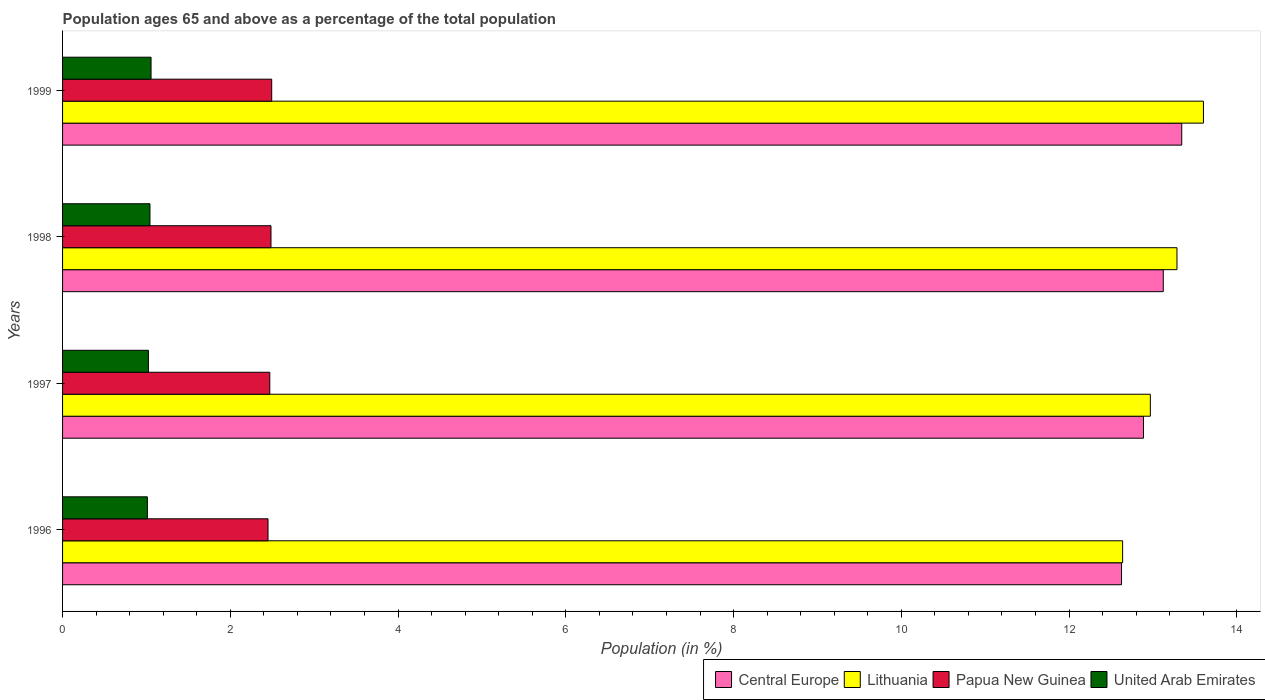How many different coloured bars are there?
Provide a succinct answer. 4. Are the number of bars on each tick of the Y-axis equal?
Ensure brevity in your answer.  Yes. How many bars are there on the 3rd tick from the top?
Provide a short and direct response. 4. How many bars are there on the 2nd tick from the bottom?
Make the answer very short. 4. In how many cases, is the number of bars for a given year not equal to the number of legend labels?
Your response must be concise. 0. What is the percentage of the population ages 65 and above in United Arab Emirates in 1999?
Your answer should be very brief. 1.05. Across all years, what is the maximum percentage of the population ages 65 and above in Papua New Guinea?
Provide a short and direct response. 2.49. Across all years, what is the minimum percentage of the population ages 65 and above in Papua New Guinea?
Keep it short and to the point. 2.45. In which year was the percentage of the population ages 65 and above in Central Europe minimum?
Offer a terse response. 1996. What is the total percentage of the population ages 65 and above in Central Europe in the graph?
Make the answer very short. 51.98. What is the difference between the percentage of the population ages 65 and above in Central Europe in 1997 and that in 1998?
Give a very brief answer. -0.24. What is the difference between the percentage of the population ages 65 and above in Lithuania in 1996 and the percentage of the population ages 65 and above in Central Europe in 1997?
Your response must be concise. -0.25. What is the average percentage of the population ages 65 and above in Papua New Guinea per year?
Your response must be concise. 2.47. In the year 1996, what is the difference between the percentage of the population ages 65 and above in Lithuania and percentage of the population ages 65 and above in Papua New Guinea?
Provide a succinct answer. 10.19. In how many years, is the percentage of the population ages 65 and above in Lithuania greater than 11.2 ?
Your response must be concise. 4. What is the ratio of the percentage of the population ages 65 and above in Papua New Guinea in 1996 to that in 1998?
Your response must be concise. 0.99. Is the percentage of the population ages 65 and above in Lithuania in 1997 less than that in 1999?
Keep it short and to the point. Yes. Is the difference between the percentage of the population ages 65 and above in Lithuania in 1998 and 1999 greater than the difference between the percentage of the population ages 65 and above in Papua New Guinea in 1998 and 1999?
Keep it short and to the point. No. What is the difference between the highest and the second highest percentage of the population ages 65 and above in United Arab Emirates?
Your answer should be compact. 0.01. What is the difference between the highest and the lowest percentage of the population ages 65 and above in Papua New Guinea?
Keep it short and to the point. 0.04. In how many years, is the percentage of the population ages 65 and above in United Arab Emirates greater than the average percentage of the population ages 65 and above in United Arab Emirates taken over all years?
Keep it short and to the point. 2. What does the 2nd bar from the top in 1999 represents?
Give a very brief answer. Papua New Guinea. What does the 2nd bar from the bottom in 1999 represents?
Provide a succinct answer. Lithuania. Is it the case that in every year, the sum of the percentage of the population ages 65 and above in Lithuania and percentage of the population ages 65 and above in Papua New Guinea is greater than the percentage of the population ages 65 and above in United Arab Emirates?
Provide a succinct answer. Yes. How many bars are there?
Your response must be concise. 16. How many years are there in the graph?
Provide a short and direct response. 4. Are the values on the major ticks of X-axis written in scientific E-notation?
Ensure brevity in your answer.  No. Where does the legend appear in the graph?
Your answer should be compact. Bottom right. How are the legend labels stacked?
Offer a terse response. Horizontal. What is the title of the graph?
Give a very brief answer. Population ages 65 and above as a percentage of the total population. Does "Middle East & North Africa (all income levels)" appear as one of the legend labels in the graph?
Your response must be concise. No. What is the label or title of the X-axis?
Keep it short and to the point. Population (in %). What is the Population (in %) of Central Europe in 1996?
Make the answer very short. 12.63. What is the Population (in %) in Lithuania in 1996?
Offer a very short reply. 12.64. What is the Population (in %) in Papua New Guinea in 1996?
Make the answer very short. 2.45. What is the Population (in %) of United Arab Emirates in 1996?
Provide a short and direct response. 1.01. What is the Population (in %) of Central Europe in 1997?
Ensure brevity in your answer.  12.89. What is the Population (in %) in Lithuania in 1997?
Your response must be concise. 12.97. What is the Population (in %) of Papua New Guinea in 1997?
Offer a very short reply. 2.47. What is the Population (in %) of United Arab Emirates in 1997?
Provide a short and direct response. 1.02. What is the Population (in %) in Central Europe in 1998?
Offer a terse response. 13.12. What is the Population (in %) of Lithuania in 1998?
Ensure brevity in your answer.  13.29. What is the Population (in %) in Papua New Guinea in 1998?
Your response must be concise. 2.48. What is the Population (in %) in United Arab Emirates in 1998?
Make the answer very short. 1.04. What is the Population (in %) of Central Europe in 1999?
Give a very brief answer. 13.34. What is the Population (in %) in Lithuania in 1999?
Ensure brevity in your answer.  13.6. What is the Population (in %) of Papua New Guinea in 1999?
Make the answer very short. 2.49. What is the Population (in %) of United Arab Emirates in 1999?
Your answer should be compact. 1.05. Across all years, what is the maximum Population (in %) of Central Europe?
Offer a very short reply. 13.34. Across all years, what is the maximum Population (in %) in Lithuania?
Ensure brevity in your answer.  13.6. Across all years, what is the maximum Population (in %) in Papua New Guinea?
Your answer should be very brief. 2.49. Across all years, what is the maximum Population (in %) in United Arab Emirates?
Offer a terse response. 1.05. Across all years, what is the minimum Population (in %) of Central Europe?
Your response must be concise. 12.63. Across all years, what is the minimum Population (in %) of Lithuania?
Ensure brevity in your answer.  12.64. Across all years, what is the minimum Population (in %) of Papua New Guinea?
Give a very brief answer. 2.45. Across all years, what is the minimum Population (in %) of United Arab Emirates?
Make the answer very short. 1.01. What is the total Population (in %) in Central Europe in the graph?
Your answer should be compact. 51.98. What is the total Population (in %) in Lithuania in the graph?
Your answer should be very brief. 52.49. What is the total Population (in %) in Papua New Guinea in the graph?
Offer a terse response. 9.9. What is the total Population (in %) in United Arab Emirates in the graph?
Offer a very short reply. 4.13. What is the difference between the Population (in %) of Central Europe in 1996 and that in 1997?
Your response must be concise. -0.26. What is the difference between the Population (in %) in Lithuania in 1996 and that in 1997?
Provide a short and direct response. -0.33. What is the difference between the Population (in %) in Papua New Guinea in 1996 and that in 1997?
Give a very brief answer. -0.02. What is the difference between the Population (in %) of United Arab Emirates in 1996 and that in 1997?
Give a very brief answer. -0.01. What is the difference between the Population (in %) of Central Europe in 1996 and that in 1998?
Keep it short and to the point. -0.5. What is the difference between the Population (in %) in Lithuania in 1996 and that in 1998?
Give a very brief answer. -0.65. What is the difference between the Population (in %) of Papua New Guinea in 1996 and that in 1998?
Provide a succinct answer. -0.04. What is the difference between the Population (in %) in United Arab Emirates in 1996 and that in 1998?
Offer a very short reply. -0.03. What is the difference between the Population (in %) of Central Europe in 1996 and that in 1999?
Provide a succinct answer. -0.72. What is the difference between the Population (in %) in Lithuania in 1996 and that in 1999?
Keep it short and to the point. -0.96. What is the difference between the Population (in %) of Papua New Guinea in 1996 and that in 1999?
Ensure brevity in your answer.  -0.04. What is the difference between the Population (in %) in United Arab Emirates in 1996 and that in 1999?
Make the answer very short. -0.04. What is the difference between the Population (in %) in Central Europe in 1997 and that in 1998?
Ensure brevity in your answer.  -0.24. What is the difference between the Population (in %) of Lithuania in 1997 and that in 1998?
Your answer should be very brief. -0.32. What is the difference between the Population (in %) in Papua New Guinea in 1997 and that in 1998?
Your answer should be compact. -0.01. What is the difference between the Population (in %) of United Arab Emirates in 1997 and that in 1998?
Your response must be concise. -0.02. What is the difference between the Population (in %) of Central Europe in 1997 and that in 1999?
Provide a short and direct response. -0.46. What is the difference between the Population (in %) of Lithuania in 1997 and that in 1999?
Provide a short and direct response. -0.63. What is the difference between the Population (in %) of Papua New Guinea in 1997 and that in 1999?
Provide a succinct answer. -0.02. What is the difference between the Population (in %) in United Arab Emirates in 1997 and that in 1999?
Keep it short and to the point. -0.03. What is the difference between the Population (in %) of Central Europe in 1998 and that in 1999?
Your answer should be compact. -0.22. What is the difference between the Population (in %) of Lithuania in 1998 and that in 1999?
Offer a terse response. -0.32. What is the difference between the Population (in %) of Papua New Guinea in 1998 and that in 1999?
Offer a very short reply. -0.01. What is the difference between the Population (in %) in United Arab Emirates in 1998 and that in 1999?
Keep it short and to the point. -0.01. What is the difference between the Population (in %) in Central Europe in 1996 and the Population (in %) in Lithuania in 1997?
Offer a very short reply. -0.34. What is the difference between the Population (in %) in Central Europe in 1996 and the Population (in %) in Papua New Guinea in 1997?
Your response must be concise. 10.15. What is the difference between the Population (in %) in Central Europe in 1996 and the Population (in %) in United Arab Emirates in 1997?
Offer a terse response. 11.6. What is the difference between the Population (in %) of Lithuania in 1996 and the Population (in %) of Papua New Guinea in 1997?
Your answer should be compact. 10.17. What is the difference between the Population (in %) in Lithuania in 1996 and the Population (in %) in United Arab Emirates in 1997?
Provide a succinct answer. 11.61. What is the difference between the Population (in %) of Papua New Guinea in 1996 and the Population (in %) of United Arab Emirates in 1997?
Offer a terse response. 1.43. What is the difference between the Population (in %) in Central Europe in 1996 and the Population (in %) in Lithuania in 1998?
Ensure brevity in your answer.  -0.66. What is the difference between the Population (in %) in Central Europe in 1996 and the Population (in %) in Papua New Guinea in 1998?
Offer a very short reply. 10.14. What is the difference between the Population (in %) of Central Europe in 1996 and the Population (in %) of United Arab Emirates in 1998?
Keep it short and to the point. 11.58. What is the difference between the Population (in %) of Lithuania in 1996 and the Population (in %) of Papua New Guinea in 1998?
Keep it short and to the point. 10.15. What is the difference between the Population (in %) of Lithuania in 1996 and the Population (in %) of United Arab Emirates in 1998?
Make the answer very short. 11.6. What is the difference between the Population (in %) of Papua New Guinea in 1996 and the Population (in %) of United Arab Emirates in 1998?
Give a very brief answer. 1.41. What is the difference between the Population (in %) of Central Europe in 1996 and the Population (in %) of Lithuania in 1999?
Provide a succinct answer. -0.98. What is the difference between the Population (in %) of Central Europe in 1996 and the Population (in %) of Papua New Guinea in 1999?
Ensure brevity in your answer.  10.13. What is the difference between the Population (in %) in Central Europe in 1996 and the Population (in %) in United Arab Emirates in 1999?
Provide a short and direct response. 11.57. What is the difference between the Population (in %) of Lithuania in 1996 and the Population (in %) of Papua New Guinea in 1999?
Make the answer very short. 10.14. What is the difference between the Population (in %) in Lithuania in 1996 and the Population (in %) in United Arab Emirates in 1999?
Provide a short and direct response. 11.58. What is the difference between the Population (in %) in Papua New Guinea in 1996 and the Population (in %) in United Arab Emirates in 1999?
Provide a succinct answer. 1.39. What is the difference between the Population (in %) of Central Europe in 1997 and the Population (in %) of Lithuania in 1998?
Give a very brief answer. -0.4. What is the difference between the Population (in %) of Central Europe in 1997 and the Population (in %) of Papua New Guinea in 1998?
Give a very brief answer. 10.4. What is the difference between the Population (in %) in Central Europe in 1997 and the Population (in %) in United Arab Emirates in 1998?
Keep it short and to the point. 11.85. What is the difference between the Population (in %) of Lithuania in 1997 and the Population (in %) of Papua New Guinea in 1998?
Keep it short and to the point. 10.48. What is the difference between the Population (in %) in Lithuania in 1997 and the Population (in %) in United Arab Emirates in 1998?
Your answer should be very brief. 11.93. What is the difference between the Population (in %) of Papua New Guinea in 1997 and the Population (in %) of United Arab Emirates in 1998?
Your response must be concise. 1.43. What is the difference between the Population (in %) in Central Europe in 1997 and the Population (in %) in Lithuania in 1999?
Your answer should be very brief. -0.71. What is the difference between the Population (in %) in Central Europe in 1997 and the Population (in %) in Papua New Guinea in 1999?
Offer a terse response. 10.39. What is the difference between the Population (in %) in Central Europe in 1997 and the Population (in %) in United Arab Emirates in 1999?
Make the answer very short. 11.83. What is the difference between the Population (in %) in Lithuania in 1997 and the Population (in %) in Papua New Guinea in 1999?
Keep it short and to the point. 10.48. What is the difference between the Population (in %) of Lithuania in 1997 and the Population (in %) of United Arab Emirates in 1999?
Provide a short and direct response. 11.91. What is the difference between the Population (in %) of Papua New Guinea in 1997 and the Population (in %) of United Arab Emirates in 1999?
Your answer should be very brief. 1.42. What is the difference between the Population (in %) in Central Europe in 1998 and the Population (in %) in Lithuania in 1999?
Provide a succinct answer. -0.48. What is the difference between the Population (in %) in Central Europe in 1998 and the Population (in %) in Papua New Guinea in 1999?
Offer a very short reply. 10.63. What is the difference between the Population (in %) in Central Europe in 1998 and the Population (in %) in United Arab Emirates in 1999?
Ensure brevity in your answer.  12.07. What is the difference between the Population (in %) of Lithuania in 1998 and the Population (in %) of Papua New Guinea in 1999?
Provide a succinct answer. 10.79. What is the difference between the Population (in %) in Lithuania in 1998 and the Population (in %) in United Arab Emirates in 1999?
Make the answer very short. 12.23. What is the difference between the Population (in %) in Papua New Guinea in 1998 and the Population (in %) in United Arab Emirates in 1999?
Your answer should be compact. 1.43. What is the average Population (in %) in Central Europe per year?
Give a very brief answer. 12.99. What is the average Population (in %) in Lithuania per year?
Provide a succinct answer. 13.12. What is the average Population (in %) in Papua New Guinea per year?
Keep it short and to the point. 2.47. What is the average Population (in %) of United Arab Emirates per year?
Give a very brief answer. 1.03. In the year 1996, what is the difference between the Population (in %) of Central Europe and Population (in %) of Lithuania?
Make the answer very short. -0.01. In the year 1996, what is the difference between the Population (in %) of Central Europe and Population (in %) of Papua New Guinea?
Provide a succinct answer. 10.18. In the year 1996, what is the difference between the Population (in %) of Central Europe and Population (in %) of United Arab Emirates?
Ensure brevity in your answer.  11.61. In the year 1996, what is the difference between the Population (in %) of Lithuania and Population (in %) of Papua New Guinea?
Give a very brief answer. 10.19. In the year 1996, what is the difference between the Population (in %) in Lithuania and Population (in %) in United Arab Emirates?
Keep it short and to the point. 11.63. In the year 1996, what is the difference between the Population (in %) in Papua New Guinea and Population (in %) in United Arab Emirates?
Keep it short and to the point. 1.44. In the year 1997, what is the difference between the Population (in %) in Central Europe and Population (in %) in Lithuania?
Offer a very short reply. -0.08. In the year 1997, what is the difference between the Population (in %) of Central Europe and Population (in %) of Papua New Guinea?
Make the answer very short. 10.42. In the year 1997, what is the difference between the Population (in %) of Central Europe and Population (in %) of United Arab Emirates?
Provide a short and direct response. 11.86. In the year 1997, what is the difference between the Population (in %) of Lithuania and Population (in %) of Papua New Guinea?
Keep it short and to the point. 10.5. In the year 1997, what is the difference between the Population (in %) in Lithuania and Population (in %) in United Arab Emirates?
Give a very brief answer. 11.95. In the year 1997, what is the difference between the Population (in %) in Papua New Guinea and Population (in %) in United Arab Emirates?
Keep it short and to the point. 1.45. In the year 1998, what is the difference between the Population (in %) of Central Europe and Population (in %) of Lithuania?
Provide a short and direct response. -0.16. In the year 1998, what is the difference between the Population (in %) of Central Europe and Population (in %) of Papua New Guinea?
Provide a succinct answer. 10.64. In the year 1998, what is the difference between the Population (in %) in Central Europe and Population (in %) in United Arab Emirates?
Make the answer very short. 12.08. In the year 1998, what is the difference between the Population (in %) of Lithuania and Population (in %) of Papua New Guinea?
Keep it short and to the point. 10.8. In the year 1998, what is the difference between the Population (in %) of Lithuania and Population (in %) of United Arab Emirates?
Keep it short and to the point. 12.24. In the year 1998, what is the difference between the Population (in %) of Papua New Guinea and Population (in %) of United Arab Emirates?
Offer a terse response. 1.44. In the year 1999, what is the difference between the Population (in %) of Central Europe and Population (in %) of Lithuania?
Offer a terse response. -0.26. In the year 1999, what is the difference between the Population (in %) of Central Europe and Population (in %) of Papua New Guinea?
Keep it short and to the point. 10.85. In the year 1999, what is the difference between the Population (in %) in Central Europe and Population (in %) in United Arab Emirates?
Provide a short and direct response. 12.29. In the year 1999, what is the difference between the Population (in %) in Lithuania and Population (in %) in Papua New Guinea?
Offer a terse response. 11.11. In the year 1999, what is the difference between the Population (in %) in Lithuania and Population (in %) in United Arab Emirates?
Give a very brief answer. 12.55. In the year 1999, what is the difference between the Population (in %) in Papua New Guinea and Population (in %) in United Arab Emirates?
Your answer should be very brief. 1.44. What is the ratio of the Population (in %) in Central Europe in 1996 to that in 1997?
Your answer should be compact. 0.98. What is the ratio of the Population (in %) of Lithuania in 1996 to that in 1997?
Ensure brevity in your answer.  0.97. What is the ratio of the Population (in %) in Papua New Guinea in 1996 to that in 1997?
Offer a very short reply. 0.99. What is the ratio of the Population (in %) in Central Europe in 1996 to that in 1998?
Provide a short and direct response. 0.96. What is the ratio of the Population (in %) in Lithuania in 1996 to that in 1998?
Your answer should be compact. 0.95. What is the ratio of the Population (in %) of Papua New Guinea in 1996 to that in 1998?
Ensure brevity in your answer.  0.99. What is the ratio of the Population (in %) in United Arab Emirates in 1996 to that in 1998?
Provide a succinct answer. 0.97. What is the ratio of the Population (in %) in Central Europe in 1996 to that in 1999?
Ensure brevity in your answer.  0.95. What is the ratio of the Population (in %) of Lithuania in 1996 to that in 1999?
Offer a terse response. 0.93. What is the ratio of the Population (in %) in Papua New Guinea in 1996 to that in 1999?
Offer a terse response. 0.98. What is the ratio of the Population (in %) of United Arab Emirates in 1996 to that in 1999?
Your answer should be very brief. 0.96. What is the ratio of the Population (in %) in Central Europe in 1997 to that in 1998?
Provide a succinct answer. 0.98. What is the ratio of the Population (in %) in Lithuania in 1997 to that in 1998?
Offer a very short reply. 0.98. What is the ratio of the Population (in %) of Papua New Guinea in 1997 to that in 1998?
Give a very brief answer. 0.99. What is the ratio of the Population (in %) in United Arab Emirates in 1997 to that in 1998?
Offer a terse response. 0.98. What is the ratio of the Population (in %) of Central Europe in 1997 to that in 1999?
Your response must be concise. 0.97. What is the ratio of the Population (in %) of Lithuania in 1997 to that in 1999?
Offer a terse response. 0.95. What is the ratio of the Population (in %) of Papua New Guinea in 1997 to that in 1999?
Offer a terse response. 0.99. What is the ratio of the Population (in %) in United Arab Emirates in 1997 to that in 1999?
Your response must be concise. 0.97. What is the ratio of the Population (in %) in Central Europe in 1998 to that in 1999?
Offer a very short reply. 0.98. What is the ratio of the Population (in %) in Lithuania in 1998 to that in 1999?
Your answer should be very brief. 0.98. What is the ratio of the Population (in %) in Papua New Guinea in 1998 to that in 1999?
Keep it short and to the point. 1. What is the ratio of the Population (in %) in United Arab Emirates in 1998 to that in 1999?
Provide a succinct answer. 0.99. What is the difference between the highest and the second highest Population (in %) of Central Europe?
Your answer should be compact. 0.22. What is the difference between the highest and the second highest Population (in %) in Lithuania?
Keep it short and to the point. 0.32. What is the difference between the highest and the second highest Population (in %) of Papua New Guinea?
Offer a terse response. 0.01. What is the difference between the highest and the second highest Population (in %) of United Arab Emirates?
Give a very brief answer. 0.01. What is the difference between the highest and the lowest Population (in %) in Central Europe?
Give a very brief answer. 0.72. What is the difference between the highest and the lowest Population (in %) of Lithuania?
Provide a succinct answer. 0.96. What is the difference between the highest and the lowest Population (in %) in Papua New Guinea?
Offer a very short reply. 0.04. What is the difference between the highest and the lowest Population (in %) in United Arab Emirates?
Offer a terse response. 0.04. 